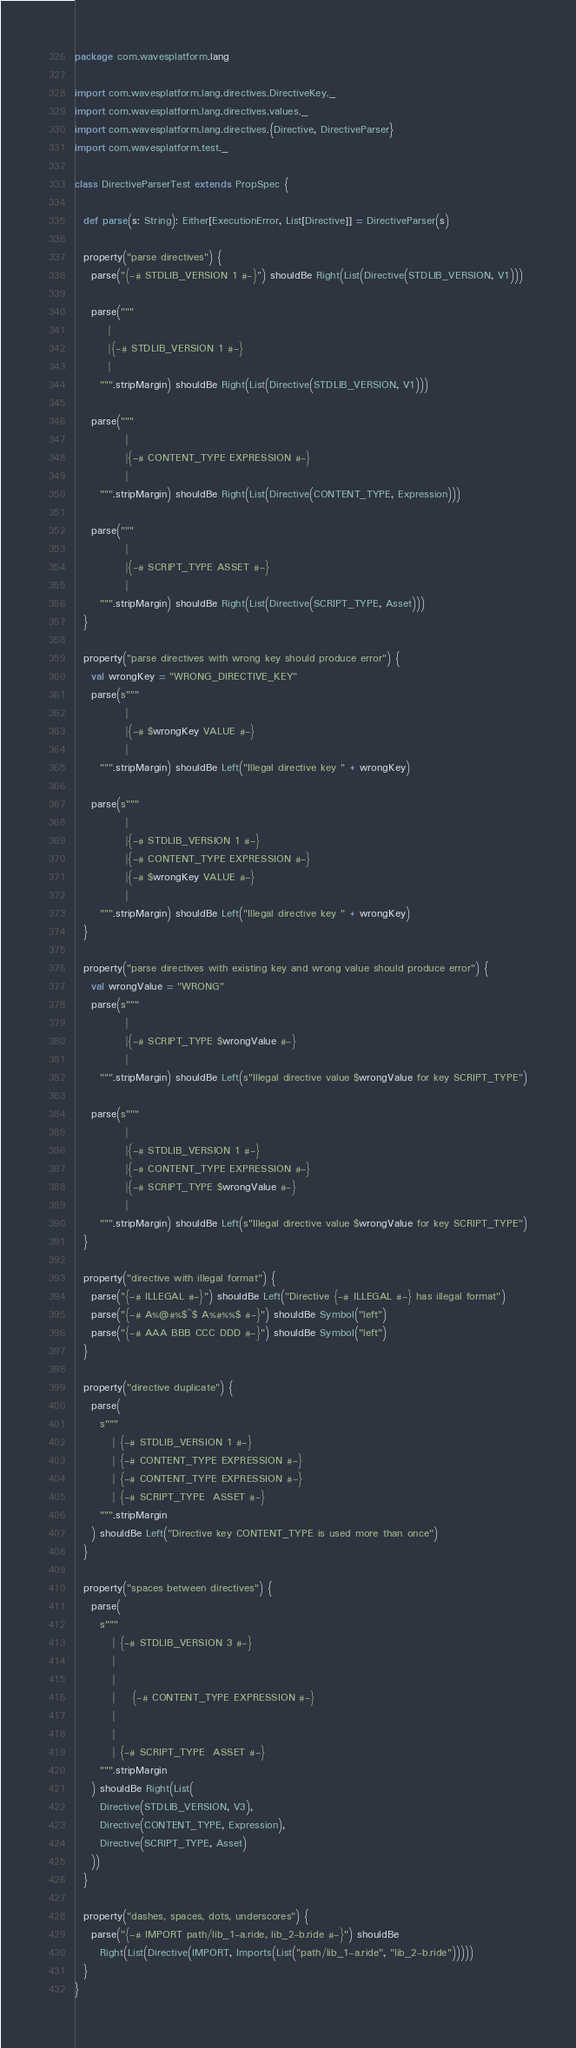<code> <loc_0><loc_0><loc_500><loc_500><_Scala_>package com.wavesplatform.lang

import com.wavesplatform.lang.directives.DirectiveKey._
import com.wavesplatform.lang.directives.values._
import com.wavesplatform.lang.directives.{Directive, DirectiveParser}
import com.wavesplatform.test._

class DirectiveParserTest extends PropSpec {

  def parse(s: String): Either[ExecutionError, List[Directive]] = DirectiveParser(s)

  property("parse directives") {
    parse("{-# STDLIB_VERSION 1 #-}") shouldBe Right(List(Directive(STDLIB_VERSION, V1)))

    parse("""
        |
        |{-# STDLIB_VERSION 1 #-}
        |
      """.stripMargin) shouldBe Right(List(Directive(STDLIB_VERSION, V1)))

    parse("""
            |
            |{-# CONTENT_TYPE EXPRESSION #-}
            |
      """.stripMargin) shouldBe Right(List(Directive(CONTENT_TYPE, Expression)))

    parse("""
            |
            |{-# SCRIPT_TYPE ASSET #-}
            |
      """.stripMargin) shouldBe Right(List(Directive(SCRIPT_TYPE, Asset)))
  }

  property("parse directives with wrong key should produce error") {
    val wrongKey = "WRONG_DIRECTIVE_KEY"
    parse(s"""
            |
            |{-# $wrongKey VALUE #-}
            |
      """.stripMargin) shouldBe Left("Illegal directive key " + wrongKey)

    parse(s"""
            |
            |{-# STDLIB_VERSION 1 #-}
            |{-# CONTENT_TYPE EXPRESSION #-}
            |{-# $wrongKey VALUE #-}
            |
      """.stripMargin) shouldBe Left("Illegal directive key " + wrongKey)
  }

  property("parse directives with existing key and wrong value should produce error") {
    val wrongValue = "WRONG"
    parse(s"""
            |
            |{-# SCRIPT_TYPE $wrongValue #-}
            |
      """.stripMargin) shouldBe Left(s"Illegal directive value $wrongValue for key SCRIPT_TYPE")

    parse(s"""
            |
            |{-# STDLIB_VERSION 1 #-}
            |{-# CONTENT_TYPE EXPRESSION #-}
            |{-# SCRIPT_TYPE $wrongValue #-}
            |
      """.stripMargin) shouldBe Left(s"Illegal directive value $wrongValue for key SCRIPT_TYPE")
  }

  property("directive with illegal format") {
    parse("{-# ILLEGAL #-}") shouldBe Left("Directive {-# ILLEGAL #-} has illegal format")
    parse("{-# A%@#%$^$ A%#%%$ #-}") shouldBe Symbol("left")
    parse("{-# AAA BBB CCC DDD #-}") shouldBe Symbol("left")
  }

  property("directive duplicate") {
    parse(
      s"""
         | {-# STDLIB_VERSION 1 #-}
         | {-# CONTENT_TYPE EXPRESSION #-}
         | {-# CONTENT_TYPE EXPRESSION #-}
         | {-# SCRIPT_TYPE  ASSET #-}
      """.stripMargin
    ) shouldBe Left("Directive key CONTENT_TYPE is used more than once")
  }

  property("spaces between directives") {
    parse(
      s"""
         | {-# STDLIB_VERSION 3 #-}
         |
         |
         |    {-# CONTENT_TYPE EXPRESSION #-}
         |
         |
         | {-# SCRIPT_TYPE  ASSET #-}
      """.stripMargin
    ) shouldBe Right(List(
      Directive(STDLIB_VERSION, V3),
      Directive(CONTENT_TYPE, Expression),
      Directive(SCRIPT_TYPE, Asset)
    ))
  }

  property("dashes, spaces, dots, underscores") {
    parse("{-# IMPORT path/lib_1-a.ride, lib_2-b.ride #-}") shouldBe
      Right(List(Directive(IMPORT, Imports(List("path/lib_1-a.ride", "lib_2-b.ride")))))
  }
}
</code> 